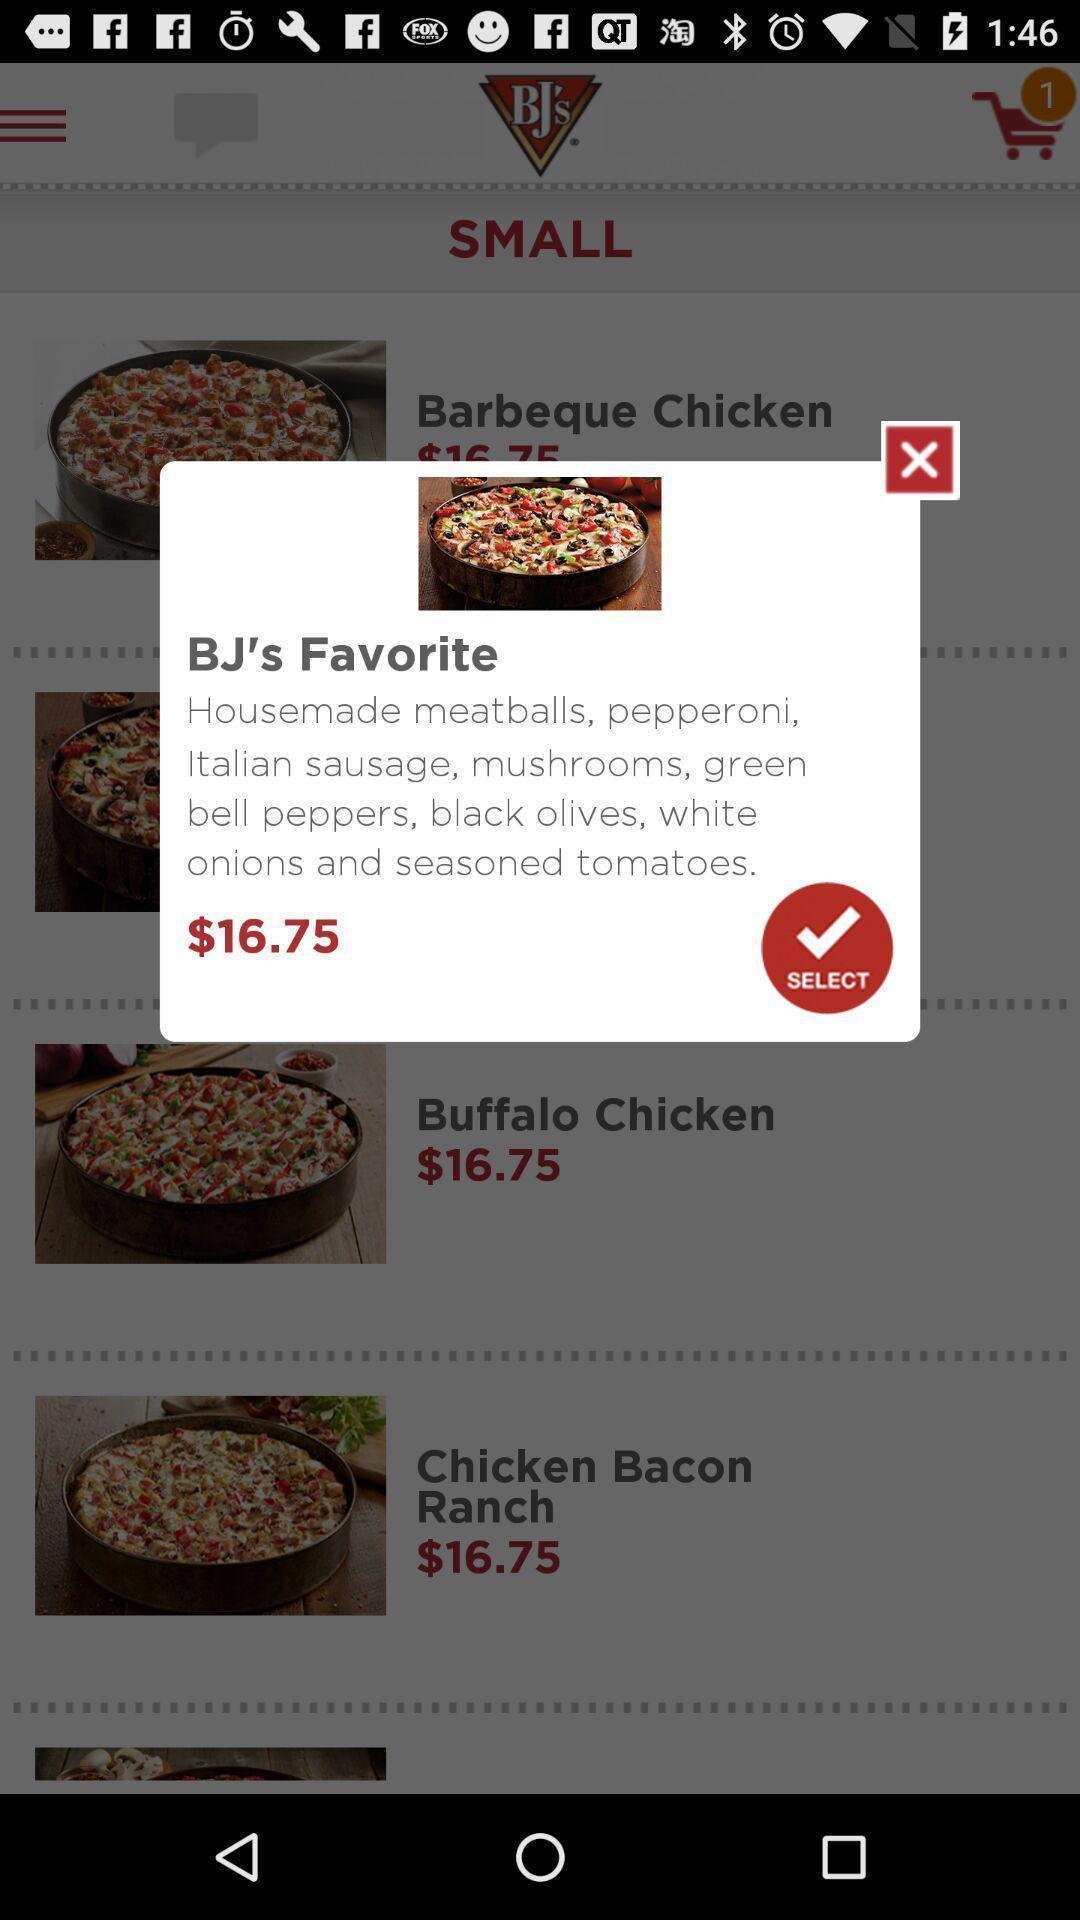Give me a narrative description of this picture. Popup of favorite food with price in the food app. 